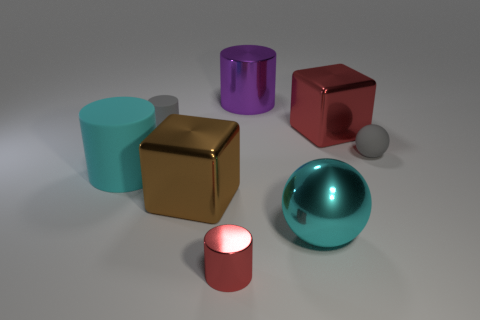Add 1 small matte things. How many objects exist? 9 Subtract all blocks. How many objects are left? 6 Add 4 big brown metallic things. How many big brown metallic things are left? 5 Add 6 tiny yellow blocks. How many tiny yellow blocks exist? 6 Subtract 0 blue blocks. How many objects are left? 8 Subtract all big metallic cylinders. Subtract all red metallic cylinders. How many objects are left? 6 